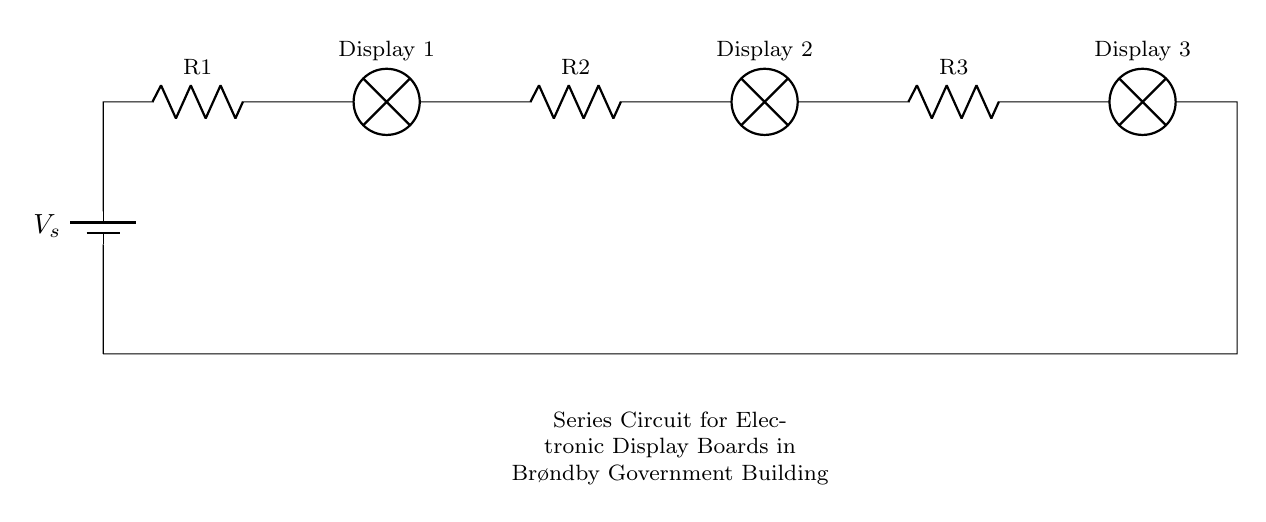What is the total number of display boards in the circuit? There are three display boards shown in the circuit, labeled as Display 1, Display 2, and Display 3. Each display board is represented by a lamp symbol in the diagram.
Answer: Three What components are present in this circuit? The circuit contains a battery (V_s), three resistors (R1, R2, R3), and three display boards (Display 1, Display 2, Display 3). These components work together to create the circuit.
Answer: Battery, resistors, display boards What type of circuit is this? This is a series circuit, indicated by the arrangement where all components are connected end-to-end in a single path for current flow.
Answer: Series circuit How many resistors are in the circuit? There are three resistors labeled as R1, R2, and R3 in the circuit. Each resistor is positioned between the display boards.
Answer: Three What happens if one display board fails? If one display board fails (for instance, if one lamp burns out), the entire circuit would stop functioning because it's a series circuit. Current cannot flow through the open circuit when one component fails.
Answer: Entire circuit fails What is the role of the resistors in this circuit? The resistors limit the current flowing through each display board, preventing them from receiving too much current, which could cause damage. They help to distribute the voltage across the boards evenly.
Answer: Limit current 